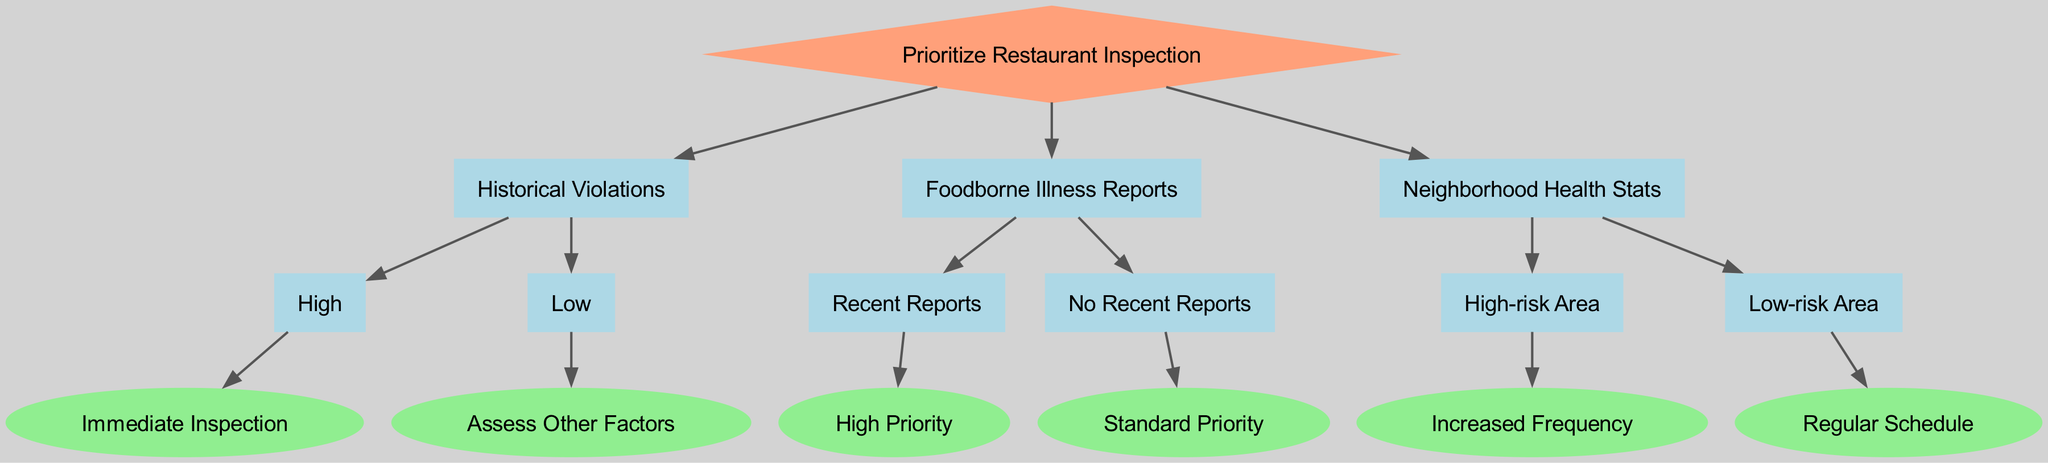What is the root node of the decision tree? The root of the tree is the initial decision point from which all choices branch out. According to the diagram, the root node is "Prioritize Restaurant Inspection."
Answer: Prioritize Restaurant Inspection How many main categories are there in the decision tree? Upon examining the structure of the tree, we can see that there are three main categories branching from the root: "Historical Violations," "Foodborne Illness Reports," and "Neighborhood Health Stats."
Answer: 3 What happens when historical violations are high? The decision path shows that if "Historical Violations" are categorized as "High," it leads directly to "Immediate Inspection," indicating an urgent need for inspection of that restaurant.
Answer: Immediate Inspection If a restaurant has low historical violations and no recent foodborne illness reports, what is the inspection priority? To find this answer, first, track the path for "Low" historical violations, which leads to "Assess Other Factors." Next, the path for "No Recent Reports" in the foodborne illness section leads to "Standard Priority." Since both decisions are independent but represent different aspects, a low historical violation doesn't dictate the foodborne illness priority; it results in assessing other factors.
Answer: Assess Other Factors What is the final outcome if the neighborhood health stats indicate a high-risk area? Moving along the decision tree, if we reach "Neighborhood Health Stats" and identify the area as "High-risk," this directs us to "Increased Frequency," showing that restaurants in such locations need to be inspected more frequently.
Answer: Increased Frequency Which node indicates a standard priority for inspections? By tracing the path in the diagram, "No Recent Reports" under "Foodborne Illness Reports" leads us to a "Standard Priority." This indicates that if there are no recent reports of illness, inspections will proceed according to a standard schedule.
Answer: Standard Priority What is the inspection outcome for a low-risk neighborhood? Following the path in the decision tree for low-risk areas under the "Neighborhood Health Stats" section leads us to "Regular Schedule," indicating that inspections in these neighborhoods can follow a standard timeline.
Answer: Regular Schedule What type of inspection occurs after identifying recent foodborne illness reports? The decision tree specifies that the identification of "Recent Reports" under "Foodborne Illness Reports" leads to a "High Priority" for inspections. This suggests increased attention is required due to recent health risks.
Answer: High Priority 